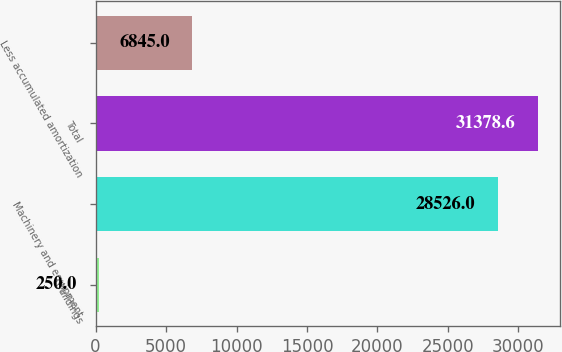Convert chart. <chart><loc_0><loc_0><loc_500><loc_500><bar_chart><fcel>Buildings<fcel>Machinery and equipment<fcel>Total<fcel>Less accumulated amortization<nl><fcel>250<fcel>28526<fcel>31378.6<fcel>6845<nl></chart> 